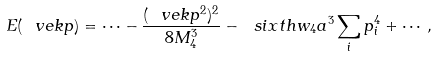Convert formula to latex. <formula><loc_0><loc_0><loc_500><loc_500>E ( \ v e k { p } ) = \cdots - \frac { ( \ v e k { p } ^ { 2 } ) ^ { 2 } } { 8 M ^ { 3 } _ { 4 } } - \ s i x t h w _ { 4 } a ^ { 3 } \sum _ { i } p _ { i } ^ { 4 } + \cdots ,</formula> 